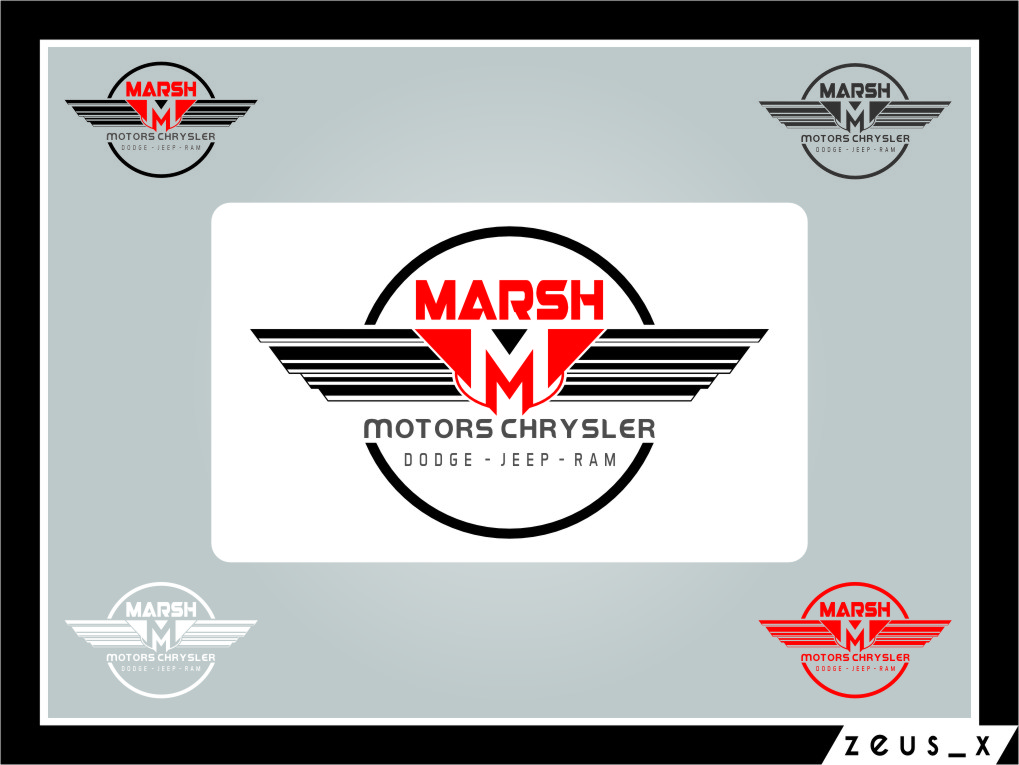What design elements of the logo suggest that it is related to the automotive industry? The design elements of the logo that suggest its relation to the automotive industry include the wing-like extensions from the central letter 'M', which evoke a sense of speed and dynamism typically associated with car logos. This visual cue is reminiscent of features found on luxury sports cars. The stark red and black color scheme contributes to its bold and aggressive aesthetic, which appeals to automotive enthusiasm. Additionally, the text 'CHRYSLER DODGE - JEEP - RAM' explicitly connects the logo with well-known car brands, placing it firmly within the automotive sector. 